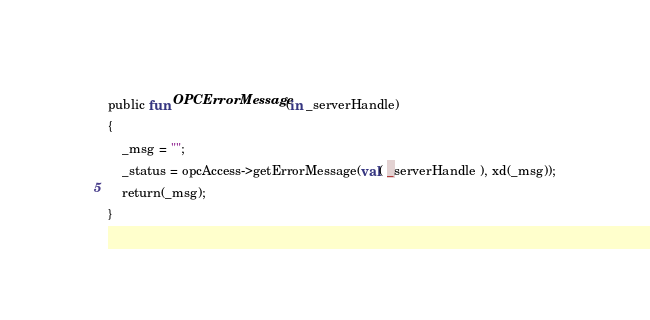Convert code to text. <code><loc_0><loc_0><loc_500><loc_500><_SML_>public fun OPCErrorMessage(in _serverHandle)
{
	_msg = "";
    _status = opcAccess->getErrorMessage(val( _serverHandle ), xd(_msg));
    return(_msg);
}
</code> 